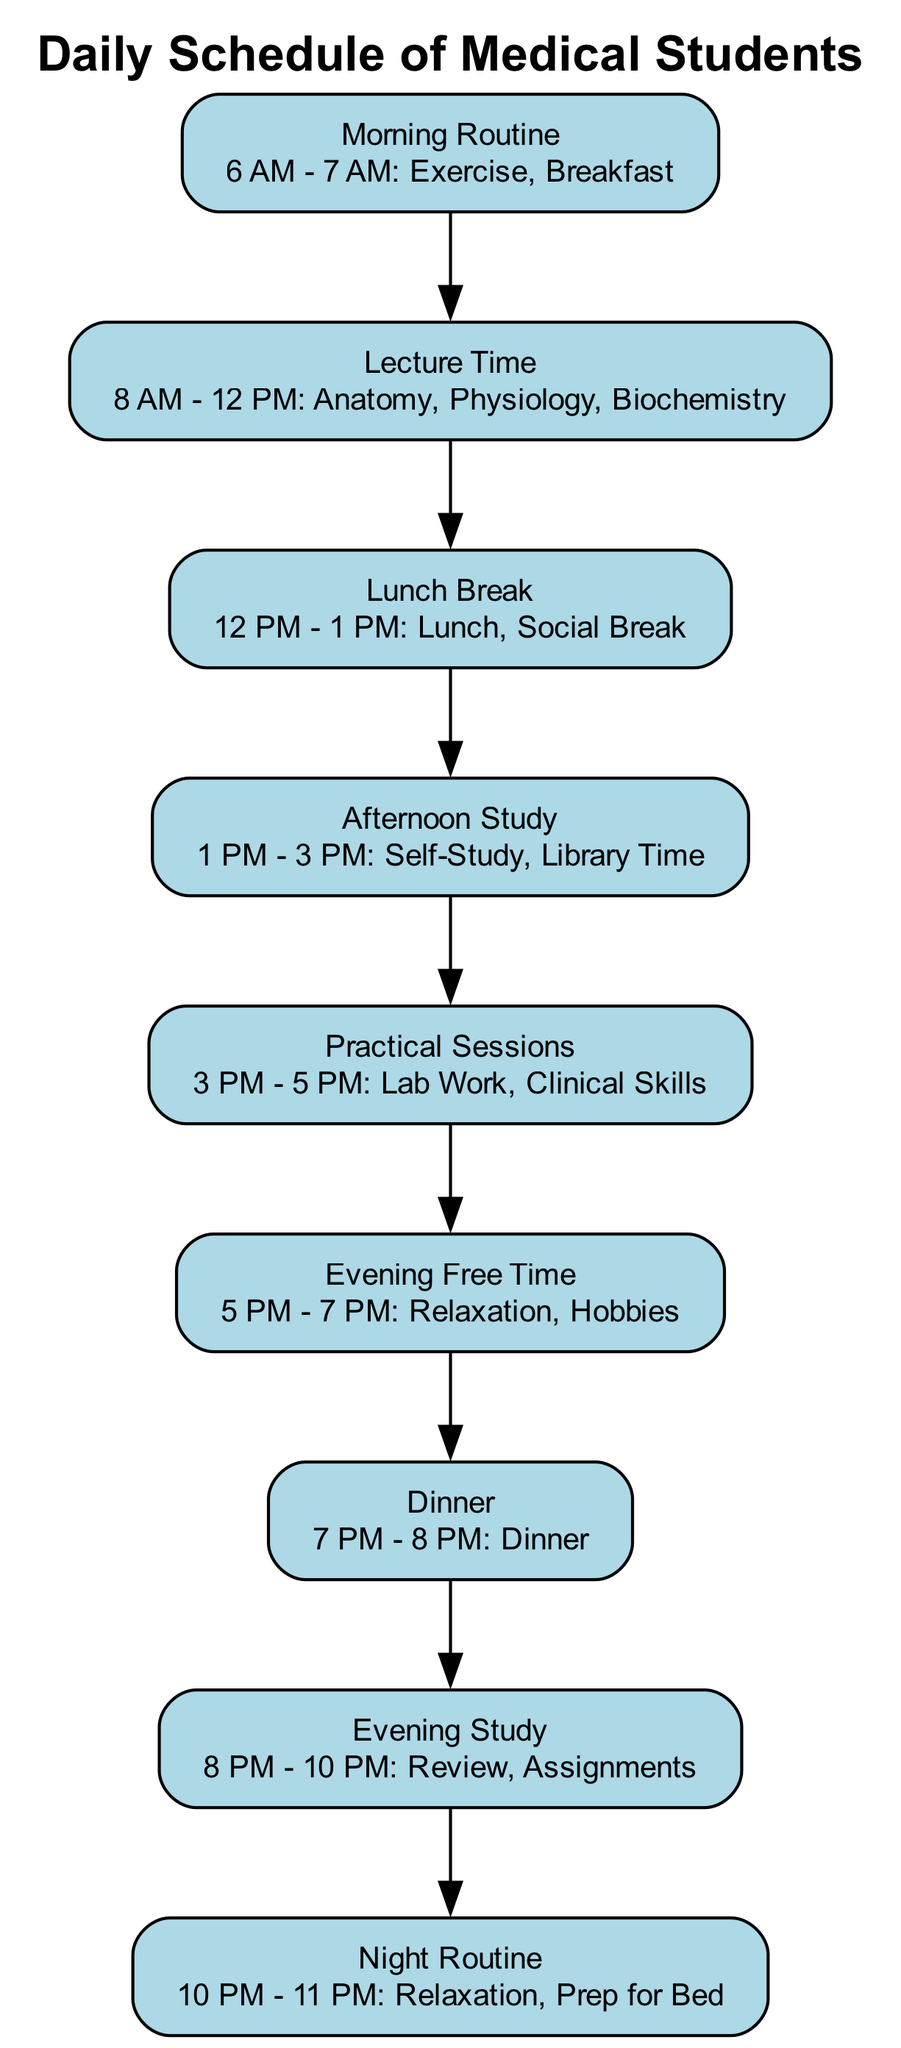What is the first activity in the daily schedule? The first node in the diagram is "Morning Routine" with details "6 AM - 7 AM: Exercise, Breakfast." Therefore, the first activity listed is Exercise and Breakfast.
Answer: Exercise, Breakfast How many total nodes are present in the diagram? By counting the nodes listed in the data, there are a total of 9 nodes representing different activities in the daily schedule.
Answer: 9 What time does the "Lunch Break" start? The "Lunch Break" node is listed as occurring from 12 PM to 1 PM. Thus, it starts at 12 PM.
Answer: 12 PM What activity occurs immediately after "Practical Sessions"? "Practical Sessions" ends at 5 PM and is connected to the next node, which is "Evening Free Time." Hence, the activity that follows is Relaxation and Hobbies.
Answer: Evening Free Time How many connections link the different nodes? Each connection represents a relationship between two nodes. The data shows a total of 8 connections indicating the flow between the 9 nodes.
Answer: 8 What time allocation do students have for "Evening Study"? The "Evening Study" is detailed from 8 PM to 10 PM, which gives a total allocation of 2 hours for this activity.
Answer: 2 hours What is the last activity of the daily schedule? The last node in the diagram is "Night Routine" with details "10 PM - 11 PM: Relaxation, Prep for Bed." Therefore, the last activity is Relaxation and Prep for Bed.
Answer: Relaxation, Prep for Bed How does relaxation fit into the daily schedule? There are two dedicated times for relaxation: "Evening Free Time" from 5 PM to 7 PM and "Night Routine" from 10 PM to 11 PM. This indicates that relaxation is incorporated into the schedule both in the evening and at night.
Answer: Evening Free Time and Night Routine What is the time span for the "Afternoon Study"? The "Afternoon Study" node runs from 1 PM to 3 PM, which means it has a time span of 2 hours.
Answer: 2 hours 